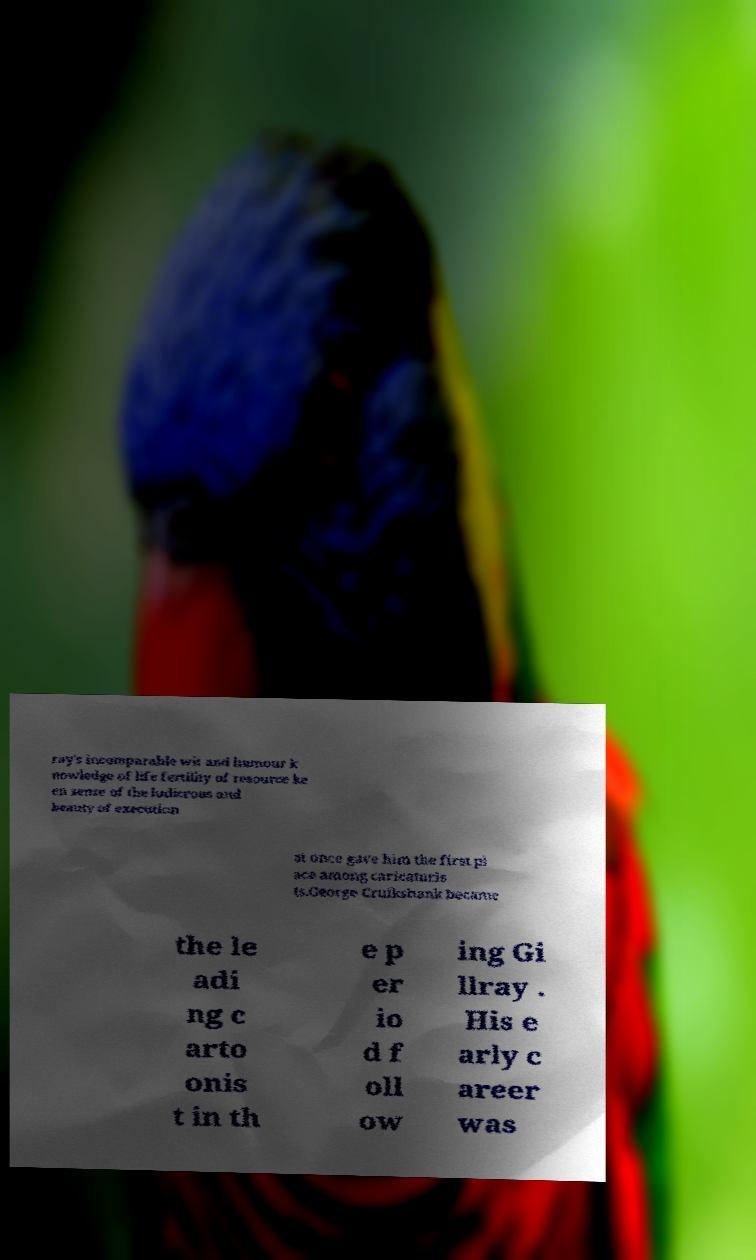Could you assist in decoding the text presented in this image and type it out clearly? ray's incomparable wit and humour k nowledge of life fertility of resource ke en sense of the ludicrous and beauty of execution at once gave him the first pl ace among caricaturis ts.George Cruikshank became the le adi ng c arto onis t in th e p er io d f oll ow ing Gi llray . His e arly c areer was 